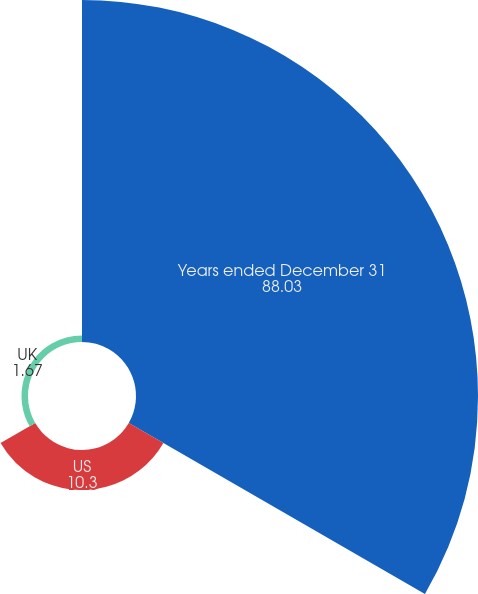<chart> <loc_0><loc_0><loc_500><loc_500><pie_chart><fcel>Years ended December 31<fcel>US<fcel>UK<nl><fcel>88.03%<fcel>10.3%<fcel>1.67%<nl></chart> 